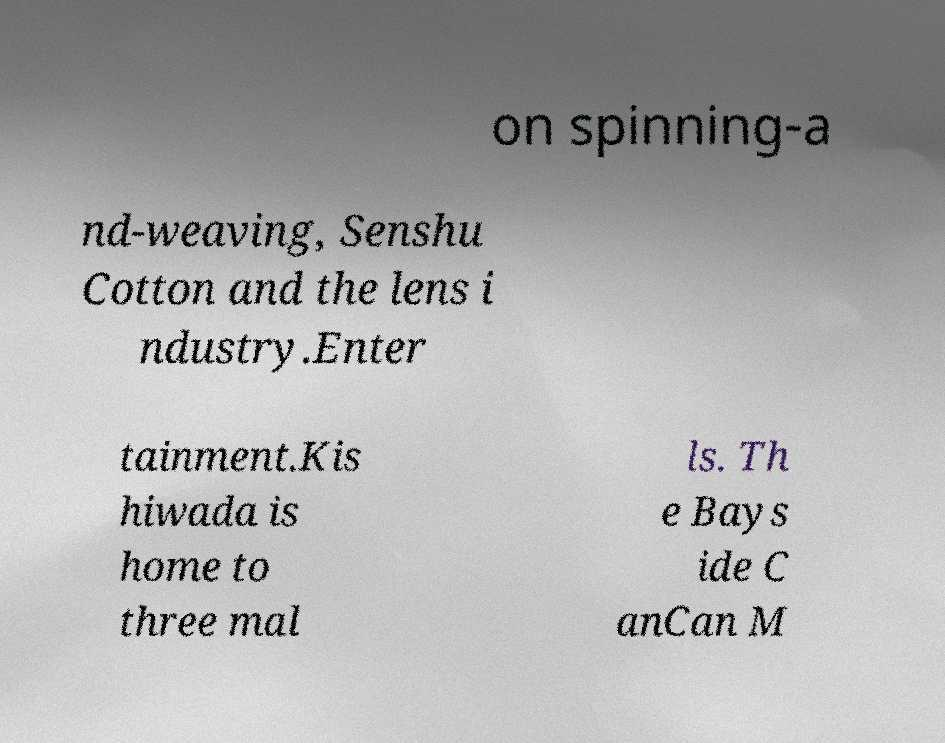What messages or text are displayed in this image? I need them in a readable, typed format. on spinning-a nd-weaving, Senshu Cotton and the lens i ndustry.Enter tainment.Kis hiwada is home to three mal ls. Th e Bays ide C anCan M 